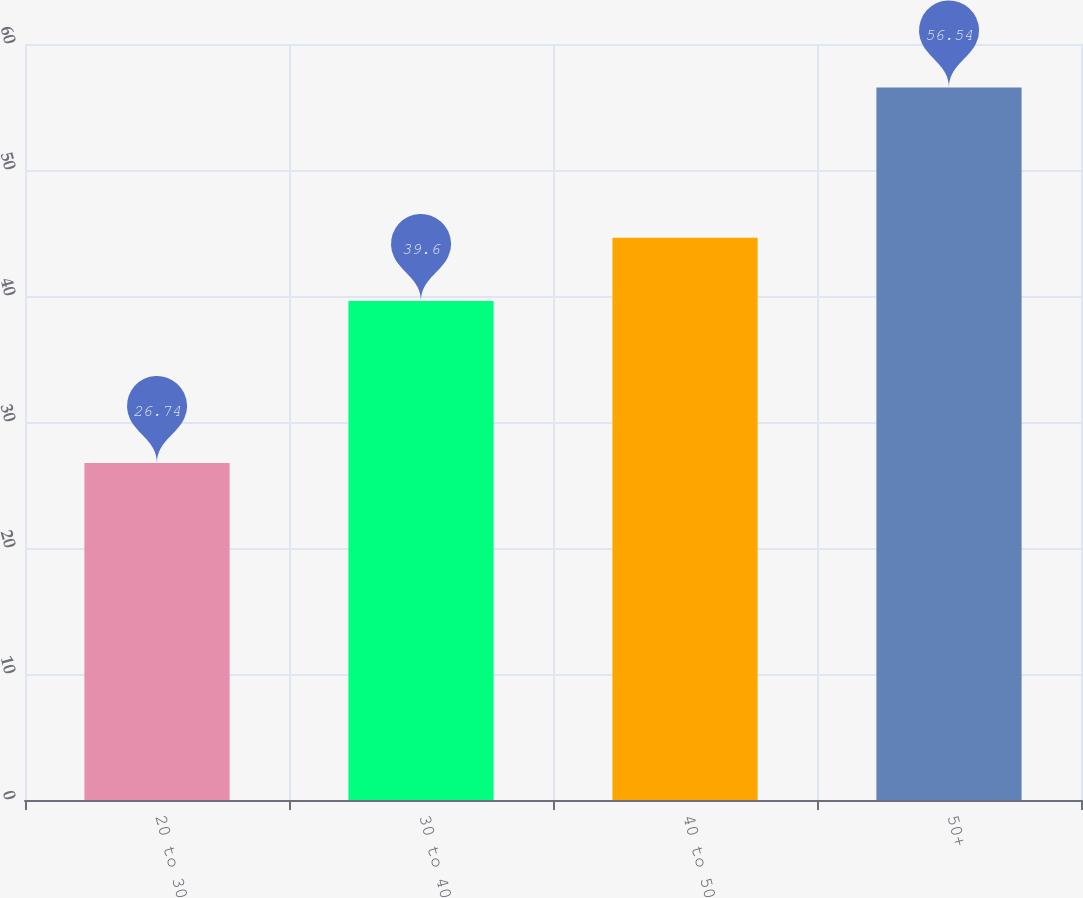<chart> <loc_0><loc_0><loc_500><loc_500><bar_chart><fcel>20 to 30<fcel>30 to 40<fcel>40 to 50<fcel>50+<nl><fcel>26.74<fcel>39.6<fcel>44.62<fcel>56.54<nl></chart> 